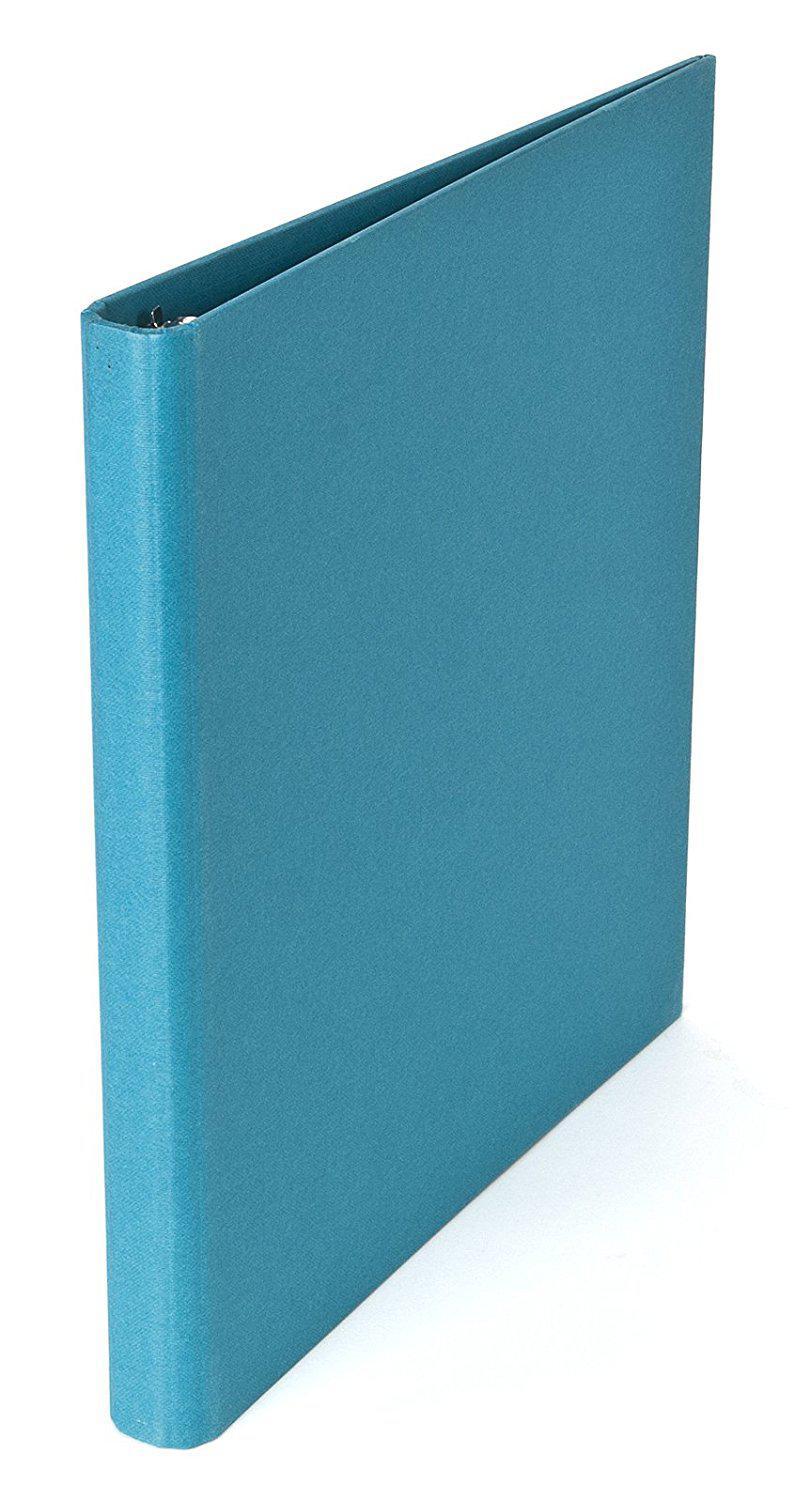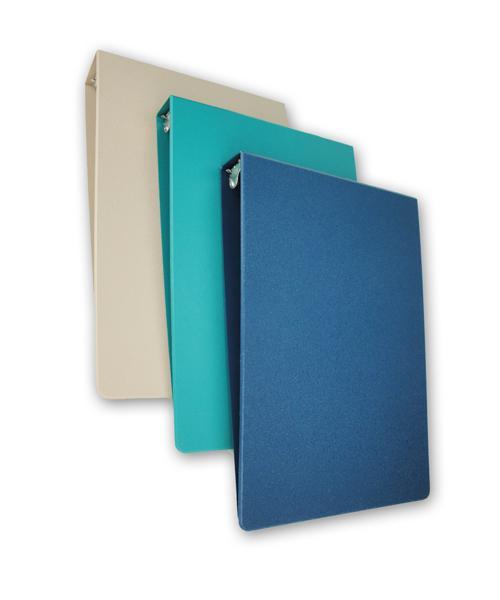The first image is the image on the left, the second image is the image on the right. Given the left and right images, does the statement "At least one binder is wide open." hold true? Answer yes or no. No. The first image is the image on the left, the second image is the image on the right. Considering the images on both sides, is "In one image a blue notebook is standing on end, while the other image shows more than one notebook." valid? Answer yes or no. Yes. 